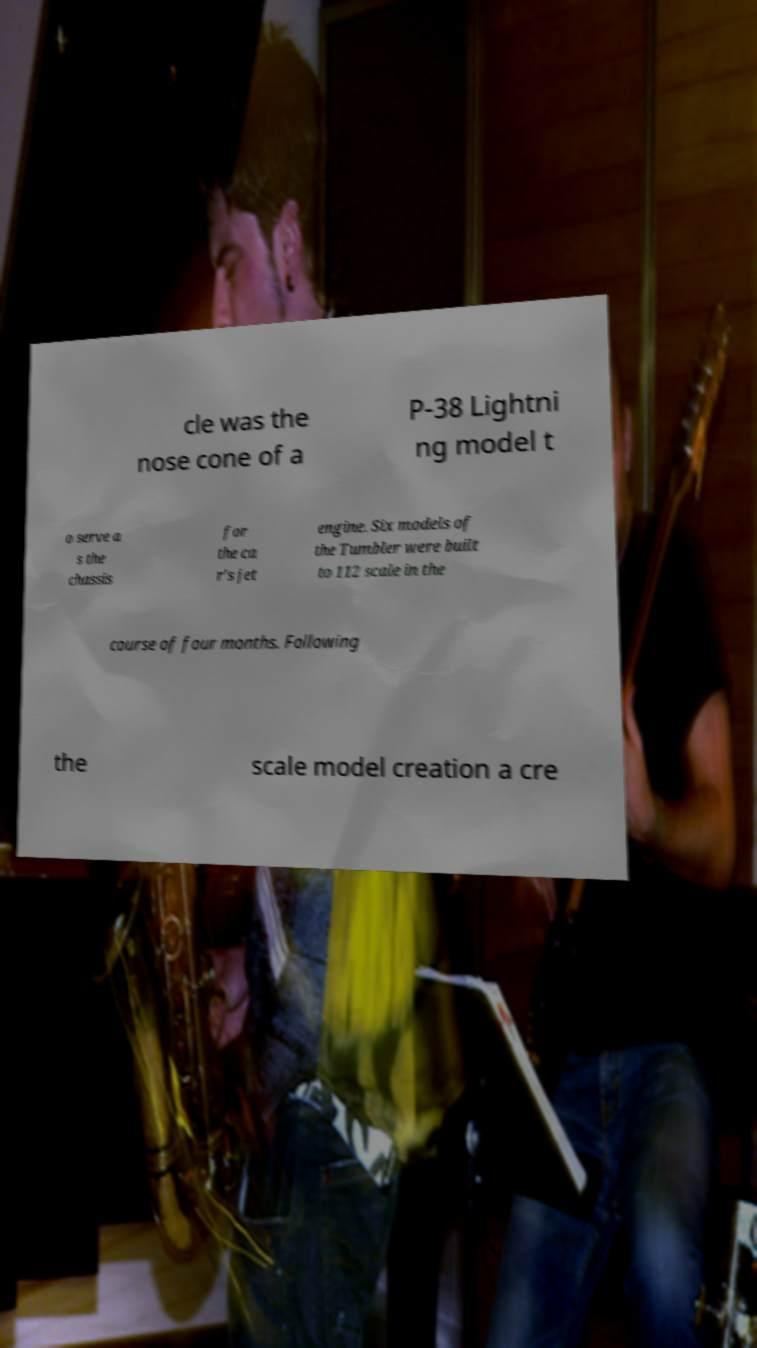Could you extract and type out the text from this image? cle was the nose cone of a P-38 Lightni ng model t o serve a s the chassis for the ca r's jet engine. Six models of the Tumbler were built to 112 scale in the course of four months. Following the scale model creation a cre 